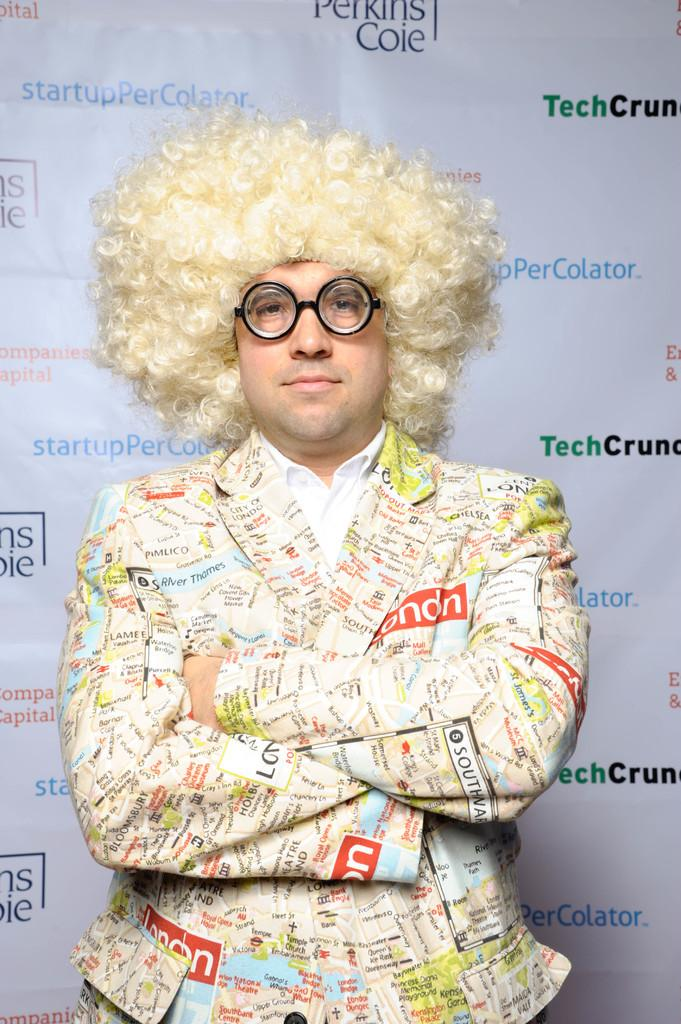What can be seen in the image? There is a person in the image. Can you describe the person's appearance? The person is wearing a shirt and spectacles. What is the person's facial expression? The person is smiling. What is the person's posture in the image? The person is standing. What is in the background of the image? There is a white color banner in the background. Can you describe the text on the banner? There are different color texts on the banner. What type of cake is being served on the patch in the image? There is no cake or patch present in the image. What color is the glove worn by the person in the image? The person in the image is not wearing a glove. 